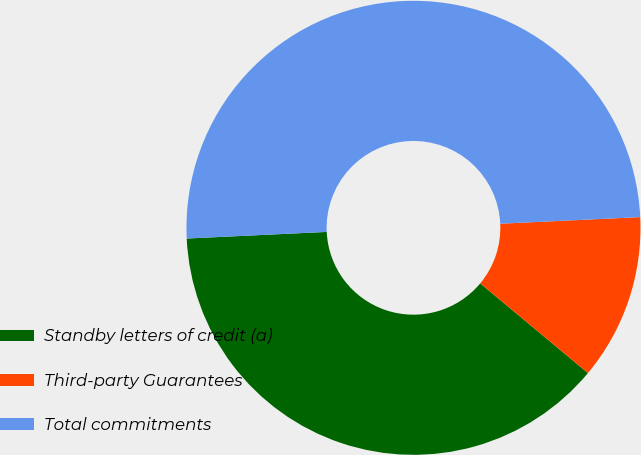<chart> <loc_0><loc_0><loc_500><loc_500><pie_chart><fcel>Standby letters of credit (a)<fcel>Third-party Guarantees<fcel>Total commitments<nl><fcel>38.2%<fcel>11.8%<fcel>50.0%<nl></chart> 